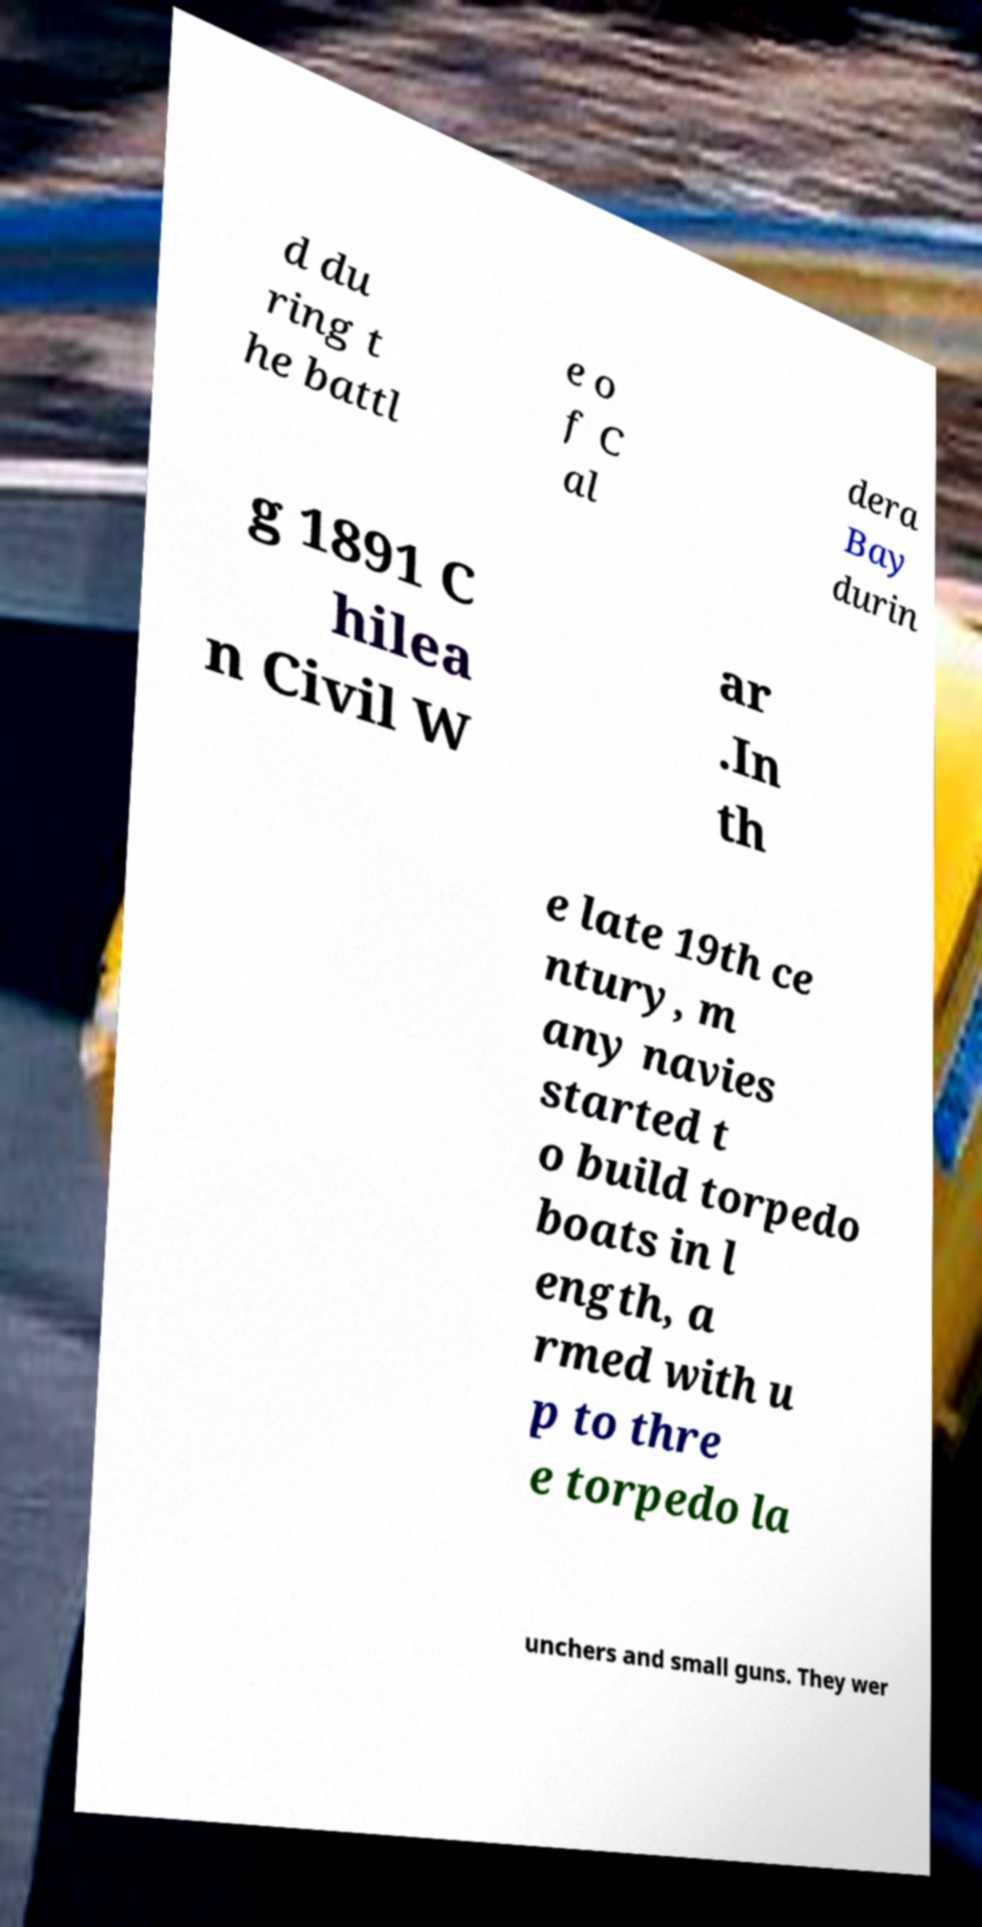I need the written content from this picture converted into text. Can you do that? d du ring t he battl e o f C al dera Bay durin g 1891 C hilea n Civil W ar .In th e late 19th ce ntury, m any navies started t o build torpedo boats in l ength, a rmed with u p to thre e torpedo la unchers and small guns. They wer 